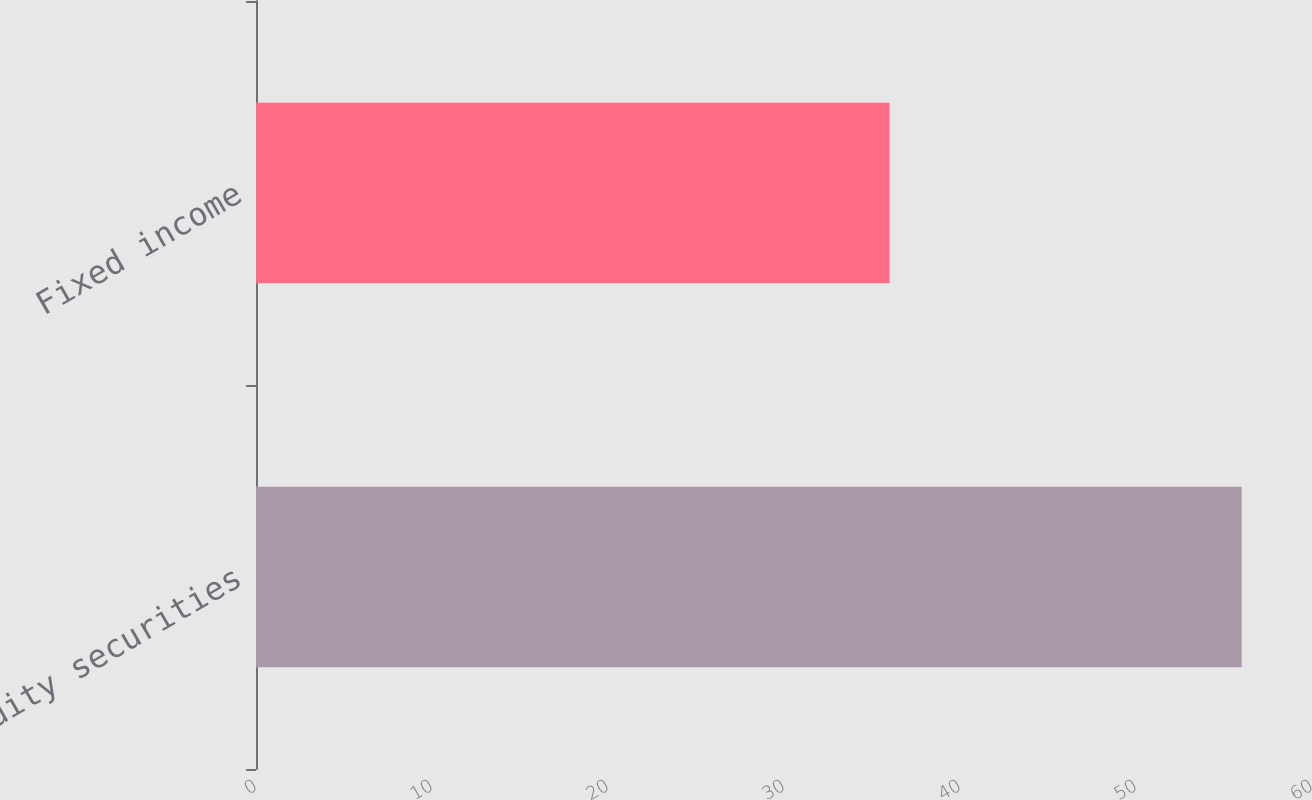Convert chart to OTSL. <chart><loc_0><loc_0><loc_500><loc_500><bar_chart><fcel>Equity securities<fcel>Fixed income<nl><fcel>56<fcel>36<nl></chart> 